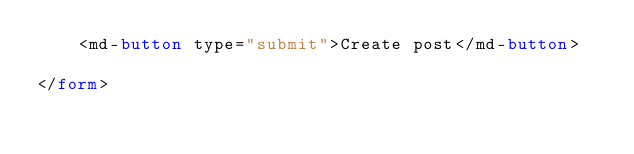<code> <loc_0><loc_0><loc_500><loc_500><_HTML_>    <md-button type="submit">Create post</md-button>

</form></code> 